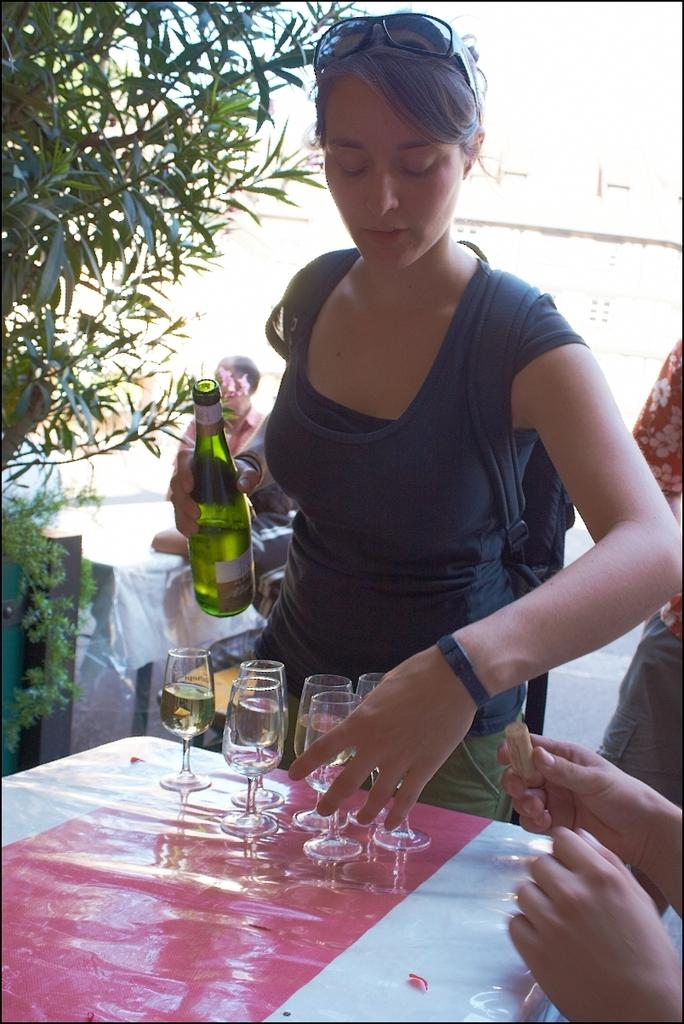What can be seen in the image that represents a living organism? There is a tree in the image. What is the woman in the image doing? The woman is standing in the image. What object is in front of the woman? There is a table in front of the woman. What items are on the table? There are glasses on the table. What is the woman holding in her hand? The woman is holding a bottle in her hand. How many trains can be seen in the image? There are no trains present in the image. Is there a fan visible in the image? There is no fan visible in the image. 